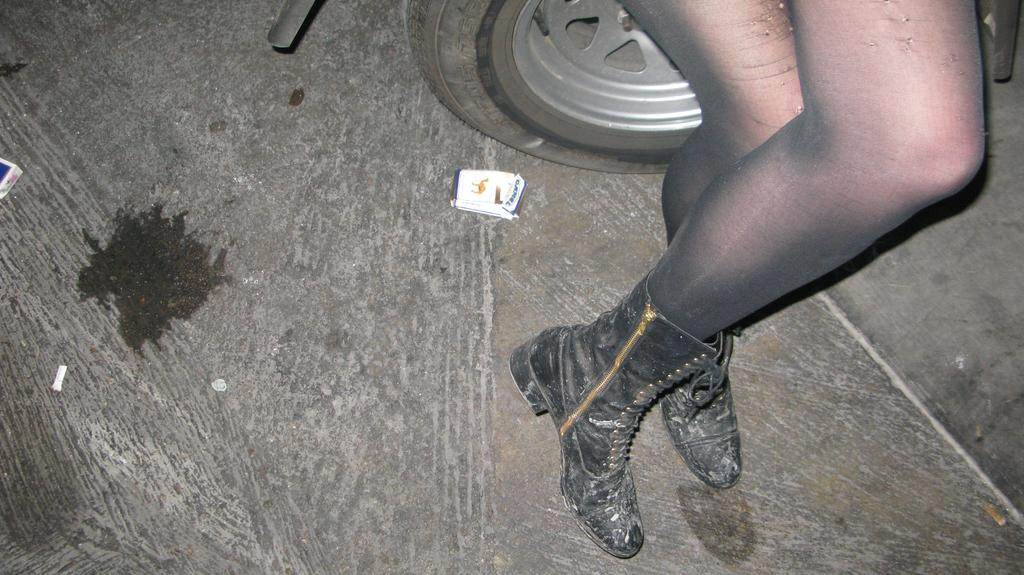Who is present in the image? There is a woman in the image. What type of footwear is the woman wearing? The woman is wearing black shoes. Where is the woman located in relation to the car? The woman is standing near a car. What else can be seen in the image besides the woman and the car? There are cars visible at the top of the image, and there is a cigarette packet on the floor. What type of pleasure can be seen in the image? There is no specific pleasure depicted in the image; it features a woman standing near a car, with other cars visible at the top and a cigarette packet on the floor. 